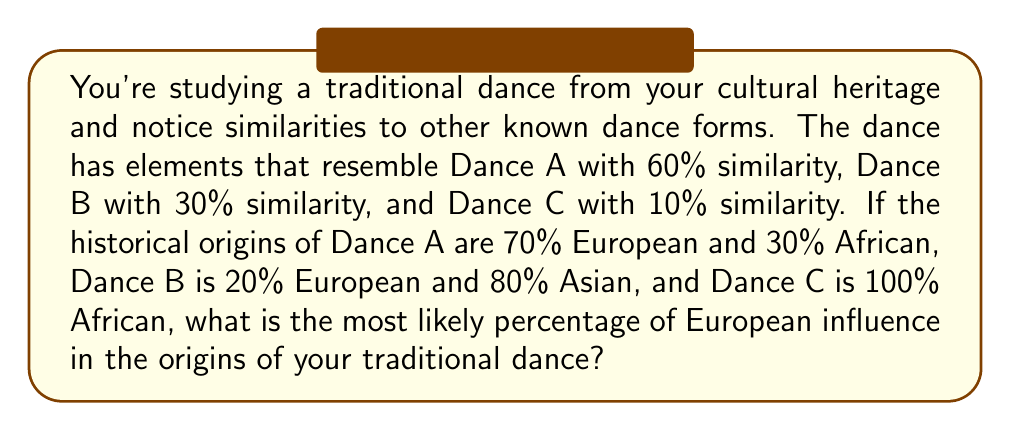Could you help me with this problem? To solve this problem, we'll use a weighted average approach:

1. First, let's define our variables:
   $x_A$, $x_B$, $x_C$ = percentage of European influence in Dances A, B, and C
   $w_A$, $w_B$, $w_C$ = weights (similarities) of Dances A, B, and C to the traditional dance

2. We know:
   $x_A = 70\%$, $x_B = 20\%$, $x_C = 0\%$
   $w_A = 60\%$, $w_B = 30\%$, $w_C = 10\%$

3. The weighted average formula for the percentage of European influence ($E$) is:

   $$E = \frac{w_A x_A + w_B x_B + w_C x_C}{w_A + w_B + w_C}$$

4. Substituting the values:

   $$E = \frac{0.60 \cdot 0.70 + 0.30 \cdot 0.20 + 0.10 \cdot 0}{0.60 + 0.30 + 0.10}$$

5. Simplifying:

   $$E = \frac{0.42 + 0.06 + 0}{1} = 0.48$$

6. Converting to a percentage:

   $$E = 0.48 \cdot 100\% = 48\%$$

Therefore, the most likely percentage of European influence in the origins of the traditional dance is 48%.
Answer: 48% 